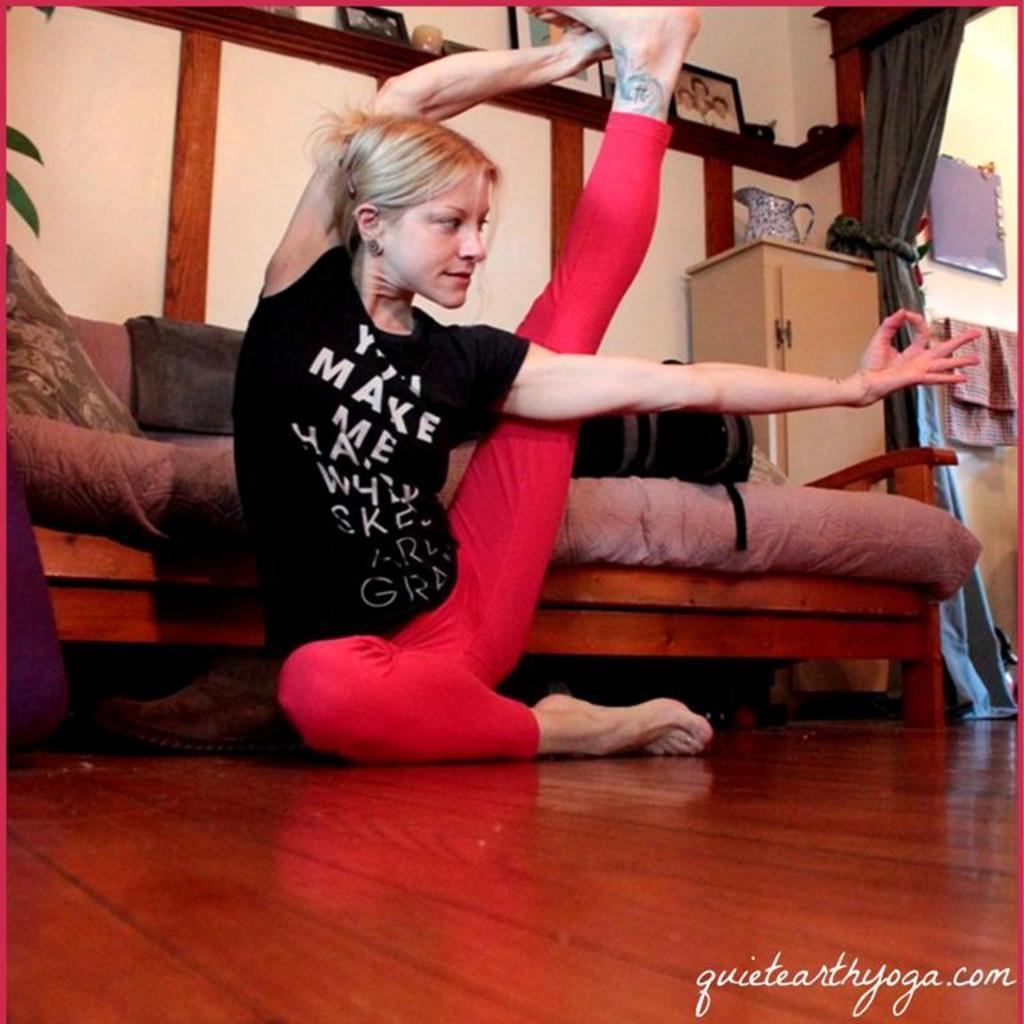Could you give a brief overview of what you see in this image? In this image we can see a lady. In the back there is a sofa. On the sofa there is a bag. Also there is a cupboard. On the cupboard there is a jug. And there is curtain. And we can see photo frames. Also we can see towel. In the right bottom corner there is text. 